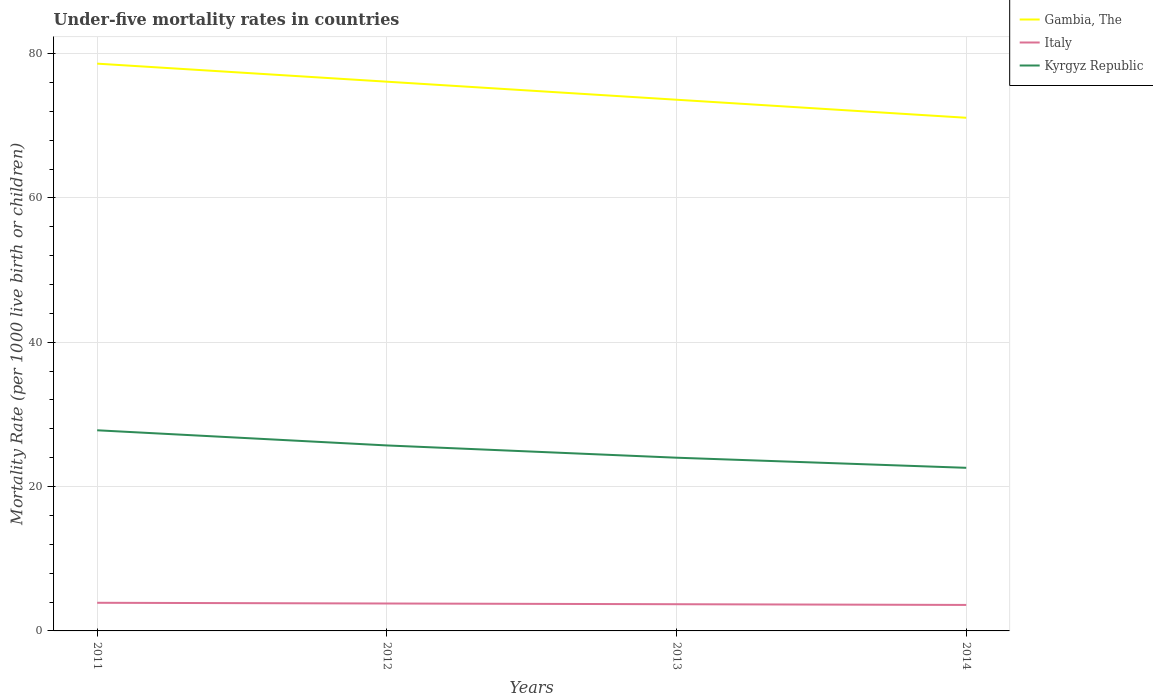How many different coloured lines are there?
Keep it short and to the point. 3. Is the number of lines equal to the number of legend labels?
Your answer should be very brief. Yes. Across all years, what is the maximum under-five mortality rate in Kyrgyz Republic?
Offer a terse response. 22.6. In which year was the under-five mortality rate in Italy maximum?
Make the answer very short. 2014. What is the total under-five mortality rate in Kyrgyz Republic in the graph?
Your response must be concise. 3.1. What is the difference between the highest and the second highest under-five mortality rate in Kyrgyz Republic?
Provide a short and direct response. 5.2. Is the under-five mortality rate in Gambia, The strictly greater than the under-five mortality rate in Kyrgyz Republic over the years?
Offer a terse response. No. How many lines are there?
Your answer should be compact. 3. Are the values on the major ticks of Y-axis written in scientific E-notation?
Make the answer very short. No. Does the graph contain any zero values?
Provide a succinct answer. No. Does the graph contain grids?
Your answer should be very brief. Yes. How many legend labels are there?
Offer a very short reply. 3. How are the legend labels stacked?
Provide a short and direct response. Vertical. What is the title of the graph?
Ensure brevity in your answer.  Under-five mortality rates in countries. What is the label or title of the X-axis?
Provide a short and direct response. Years. What is the label or title of the Y-axis?
Give a very brief answer. Mortality Rate (per 1000 live birth or children). What is the Mortality Rate (per 1000 live birth or children) in Gambia, The in 2011?
Your answer should be compact. 78.6. What is the Mortality Rate (per 1000 live birth or children) in Italy in 2011?
Provide a succinct answer. 3.9. What is the Mortality Rate (per 1000 live birth or children) of Kyrgyz Republic in 2011?
Offer a very short reply. 27.8. What is the Mortality Rate (per 1000 live birth or children) of Gambia, The in 2012?
Give a very brief answer. 76.1. What is the Mortality Rate (per 1000 live birth or children) in Kyrgyz Republic in 2012?
Provide a succinct answer. 25.7. What is the Mortality Rate (per 1000 live birth or children) in Gambia, The in 2013?
Give a very brief answer. 73.6. What is the Mortality Rate (per 1000 live birth or children) in Italy in 2013?
Provide a short and direct response. 3.7. What is the Mortality Rate (per 1000 live birth or children) in Gambia, The in 2014?
Your answer should be compact. 71.1. What is the Mortality Rate (per 1000 live birth or children) in Italy in 2014?
Offer a very short reply. 3.6. What is the Mortality Rate (per 1000 live birth or children) of Kyrgyz Republic in 2014?
Your answer should be very brief. 22.6. Across all years, what is the maximum Mortality Rate (per 1000 live birth or children) of Gambia, The?
Your answer should be very brief. 78.6. Across all years, what is the maximum Mortality Rate (per 1000 live birth or children) in Italy?
Offer a terse response. 3.9. Across all years, what is the maximum Mortality Rate (per 1000 live birth or children) in Kyrgyz Republic?
Keep it short and to the point. 27.8. Across all years, what is the minimum Mortality Rate (per 1000 live birth or children) in Gambia, The?
Offer a very short reply. 71.1. Across all years, what is the minimum Mortality Rate (per 1000 live birth or children) of Italy?
Your answer should be very brief. 3.6. Across all years, what is the minimum Mortality Rate (per 1000 live birth or children) in Kyrgyz Republic?
Keep it short and to the point. 22.6. What is the total Mortality Rate (per 1000 live birth or children) of Gambia, The in the graph?
Ensure brevity in your answer.  299.4. What is the total Mortality Rate (per 1000 live birth or children) of Kyrgyz Republic in the graph?
Your answer should be very brief. 100.1. What is the difference between the Mortality Rate (per 1000 live birth or children) of Italy in 2011 and that in 2013?
Your answer should be compact. 0.2. What is the difference between the Mortality Rate (per 1000 live birth or children) in Gambia, The in 2012 and that in 2013?
Your answer should be compact. 2.5. What is the difference between the Mortality Rate (per 1000 live birth or children) in Italy in 2012 and that in 2013?
Provide a succinct answer. 0.1. What is the difference between the Mortality Rate (per 1000 live birth or children) of Gambia, The in 2012 and that in 2014?
Keep it short and to the point. 5. What is the difference between the Mortality Rate (per 1000 live birth or children) in Kyrgyz Republic in 2012 and that in 2014?
Make the answer very short. 3.1. What is the difference between the Mortality Rate (per 1000 live birth or children) of Gambia, The in 2013 and that in 2014?
Ensure brevity in your answer.  2.5. What is the difference between the Mortality Rate (per 1000 live birth or children) of Gambia, The in 2011 and the Mortality Rate (per 1000 live birth or children) of Italy in 2012?
Keep it short and to the point. 74.8. What is the difference between the Mortality Rate (per 1000 live birth or children) in Gambia, The in 2011 and the Mortality Rate (per 1000 live birth or children) in Kyrgyz Republic in 2012?
Keep it short and to the point. 52.9. What is the difference between the Mortality Rate (per 1000 live birth or children) of Italy in 2011 and the Mortality Rate (per 1000 live birth or children) of Kyrgyz Republic in 2012?
Your response must be concise. -21.8. What is the difference between the Mortality Rate (per 1000 live birth or children) in Gambia, The in 2011 and the Mortality Rate (per 1000 live birth or children) in Italy in 2013?
Provide a short and direct response. 74.9. What is the difference between the Mortality Rate (per 1000 live birth or children) of Gambia, The in 2011 and the Mortality Rate (per 1000 live birth or children) of Kyrgyz Republic in 2013?
Your answer should be very brief. 54.6. What is the difference between the Mortality Rate (per 1000 live birth or children) in Italy in 2011 and the Mortality Rate (per 1000 live birth or children) in Kyrgyz Republic in 2013?
Give a very brief answer. -20.1. What is the difference between the Mortality Rate (per 1000 live birth or children) in Gambia, The in 2011 and the Mortality Rate (per 1000 live birth or children) in Italy in 2014?
Provide a succinct answer. 75. What is the difference between the Mortality Rate (per 1000 live birth or children) in Italy in 2011 and the Mortality Rate (per 1000 live birth or children) in Kyrgyz Republic in 2014?
Your response must be concise. -18.7. What is the difference between the Mortality Rate (per 1000 live birth or children) of Gambia, The in 2012 and the Mortality Rate (per 1000 live birth or children) of Italy in 2013?
Your answer should be compact. 72.4. What is the difference between the Mortality Rate (per 1000 live birth or children) in Gambia, The in 2012 and the Mortality Rate (per 1000 live birth or children) in Kyrgyz Republic in 2013?
Ensure brevity in your answer.  52.1. What is the difference between the Mortality Rate (per 1000 live birth or children) in Italy in 2012 and the Mortality Rate (per 1000 live birth or children) in Kyrgyz Republic in 2013?
Your answer should be very brief. -20.2. What is the difference between the Mortality Rate (per 1000 live birth or children) in Gambia, The in 2012 and the Mortality Rate (per 1000 live birth or children) in Italy in 2014?
Your response must be concise. 72.5. What is the difference between the Mortality Rate (per 1000 live birth or children) in Gambia, The in 2012 and the Mortality Rate (per 1000 live birth or children) in Kyrgyz Republic in 2014?
Your response must be concise. 53.5. What is the difference between the Mortality Rate (per 1000 live birth or children) of Italy in 2012 and the Mortality Rate (per 1000 live birth or children) of Kyrgyz Republic in 2014?
Keep it short and to the point. -18.8. What is the difference between the Mortality Rate (per 1000 live birth or children) in Gambia, The in 2013 and the Mortality Rate (per 1000 live birth or children) in Italy in 2014?
Provide a short and direct response. 70. What is the difference between the Mortality Rate (per 1000 live birth or children) of Italy in 2013 and the Mortality Rate (per 1000 live birth or children) of Kyrgyz Republic in 2014?
Give a very brief answer. -18.9. What is the average Mortality Rate (per 1000 live birth or children) in Gambia, The per year?
Your answer should be very brief. 74.85. What is the average Mortality Rate (per 1000 live birth or children) of Italy per year?
Keep it short and to the point. 3.75. What is the average Mortality Rate (per 1000 live birth or children) of Kyrgyz Republic per year?
Ensure brevity in your answer.  25.02. In the year 2011, what is the difference between the Mortality Rate (per 1000 live birth or children) of Gambia, The and Mortality Rate (per 1000 live birth or children) of Italy?
Your answer should be very brief. 74.7. In the year 2011, what is the difference between the Mortality Rate (per 1000 live birth or children) of Gambia, The and Mortality Rate (per 1000 live birth or children) of Kyrgyz Republic?
Your answer should be very brief. 50.8. In the year 2011, what is the difference between the Mortality Rate (per 1000 live birth or children) in Italy and Mortality Rate (per 1000 live birth or children) in Kyrgyz Republic?
Offer a terse response. -23.9. In the year 2012, what is the difference between the Mortality Rate (per 1000 live birth or children) in Gambia, The and Mortality Rate (per 1000 live birth or children) in Italy?
Keep it short and to the point. 72.3. In the year 2012, what is the difference between the Mortality Rate (per 1000 live birth or children) of Gambia, The and Mortality Rate (per 1000 live birth or children) of Kyrgyz Republic?
Keep it short and to the point. 50.4. In the year 2012, what is the difference between the Mortality Rate (per 1000 live birth or children) in Italy and Mortality Rate (per 1000 live birth or children) in Kyrgyz Republic?
Your answer should be very brief. -21.9. In the year 2013, what is the difference between the Mortality Rate (per 1000 live birth or children) of Gambia, The and Mortality Rate (per 1000 live birth or children) of Italy?
Your answer should be very brief. 69.9. In the year 2013, what is the difference between the Mortality Rate (per 1000 live birth or children) in Gambia, The and Mortality Rate (per 1000 live birth or children) in Kyrgyz Republic?
Provide a succinct answer. 49.6. In the year 2013, what is the difference between the Mortality Rate (per 1000 live birth or children) in Italy and Mortality Rate (per 1000 live birth or children) in Kyrgyz Republic?
Make the answer very short. -20.3. In the year 2014, what is the difference between the Mortality Rate (per 1000 live birth or children) in Gambia, The and Mortality Rate (per 1000 live birth or children) in Italy?
Your answer should be compact. 67.5. In the year 2014, what is the difference between the Mortality Rate (per 1000 live birth or children) in Gambia, The and Mortality Rate (per 1000 live birth or children) in Kyrgyz Republic?
Your answer should be very brief. 48.5. What is the ratio of the Mortality Rate (per 1000 live birth or children) of Gambia, The in 2011 to that in 2012?
Give a very brief answer. 1.03. What is the ratio of the Mortality Rate (per 1000 live birth or children) of Italy in 2011 to that in 2012?
Offer a very short reply. 1.03. What is the ratio of the Mortality Rate (per 1000 live birth or children) of Kyrgyz Republic in 2011 to that in 2012?
Your answer should be compact. 1.08. What is the ratio of the Mortality Rate (per 1000 live birth or children) in Gambia, The in 2011 to that in 2013?
Offer a very short reply. 1.07. What is the ratio of the Mortality Rate (per 1000 live birth or children) of Italy in 2011 to that in 2013?
Your answer should be compact. 1.05. What is the ratio of the Mortality Rate (per 1000 live birth or children) in Kyrgyz Republic in 2011 to that in 2013?
Provide a short and direct response. 1.16. What is the ratio of the Mortality Rate (per 1000 live birth or children) in Gambia, The in 2011 to that in 2014?
Make the answer very short. 1.11. What is the ratio of the Mortality Rate (per 1000 live birth or children) of Kyrgyz Republic in 2011 to that in 2014?
Your answer should be compact. 1.23. What is the ratio of the Mortality Rate (per 1000 live birth or children) in Gambia, The in 2012 to that in 2013?
Your response must be concise. 1.03. What is the ratio of the Mortality Rate (per 1000 live birth or children) in Kyrgyz Republic in 2012 to that in 2013?
Ensure brevity in your answer.  1.07. What is the ratio of the Mortality Rate (per 1000 live birth or children) of Gambia, The in 2012 to that in 2014?
Your answer should be very brief. 1.07. What is the ratio of the Mortality Rate (per 1000 live birth or children) of Italy in 2012 to that in 2014?
Offer a very short reply. 1.06. What is the ratio of the Mortality Rate (per 1000 live birth or children) of Kyrgyz Republic in 2012 to that in 2014?
Your answer should be very brief. 1.14. What is the ratio of the Mortality Rate (per 1000 live birth or children) of Gambia, The in 2013 to that in 2014?
Keep it short and to the point. 1.04. What is the ratio of the Mortality Rate (per 1000 live birth or children) of Italy in 2013 to that in 2014?
Ensure brevity in your answer.  1.03. What is the ratio of the Mortality Rate (per 1000 live birth or children) in Kyrgyz Republic in 2013 to that in 2014?
Provide a succinct answer. 1.06. What is the difference between the highest and the second highest Mortality Rate (per 1000 live birth or children) of Gambia, The?
Offer a terse response. 2.5. What is the difference between the highest and the second highest Mortality Rate (per 1000 live birth or children) in Italy?
Your answer should be very brief. 0.1. What is the difference between the highest and the second highest Mortality Rate (per 1000 live birth or children) in Kyrgyz Republic?
Give a very brief answer. 2.1. What is the difference between the highest and the lowest Mortality Rate (per 1000 live birth or children) in Gambia, The?
Provide a succinct answer. 7.5. What is the difference between the highest and the lowest Mortality Rate (per 1000 live birth or children) in Italy?
Your response must be concise. 0.3. 